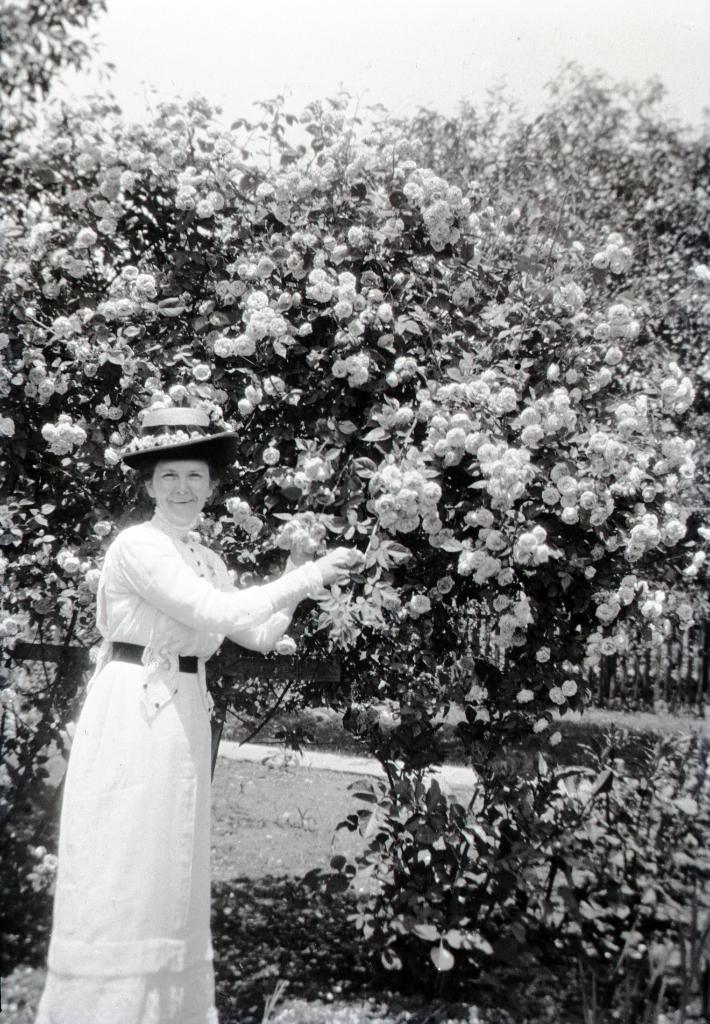What is the color scheme of the image? The image is black and white. Who is present in the image? There is a woman in the image. What is the woman wearing on her head? The woman is wearing a hat. What can be seen in the background of the image? There is a flower tree in the background of the image. What is the temperature in the image? The image is black and white, so it does not convey temperature information. Additionally, the image is a still photograph and does not depict any weather conditions. --- Facts: 1. There is a car in the image. 2. The car is red. 3. The car has four wheels. 4. There is a road in the image. 5. The road is paved. Absurd Topics: ocean, dance, laughter Conversation: What is the main subject of the image? The main subject of the image is a car. What color is the car? The car is red. How many wheels does the car have? The car has four wheels. What can be seen in the background of the image? There is a road in the image. What type of road is visible in the image? The road is paved. Reasoning: Let's think step by step in order to produce the conversation. We start by identifying the main subject in the image, which is the car. Then, we describe the car's appearance by mentioning its color and the number of wheels. Finally, we expand the conversation to include the background of the image, which features a paved road. Absurd Question/Answer: Can you hear the laughter of the people in the image? The image is a still photograph, so there is no sound or laughter present. Additionally, there is no indication of people in the image. 